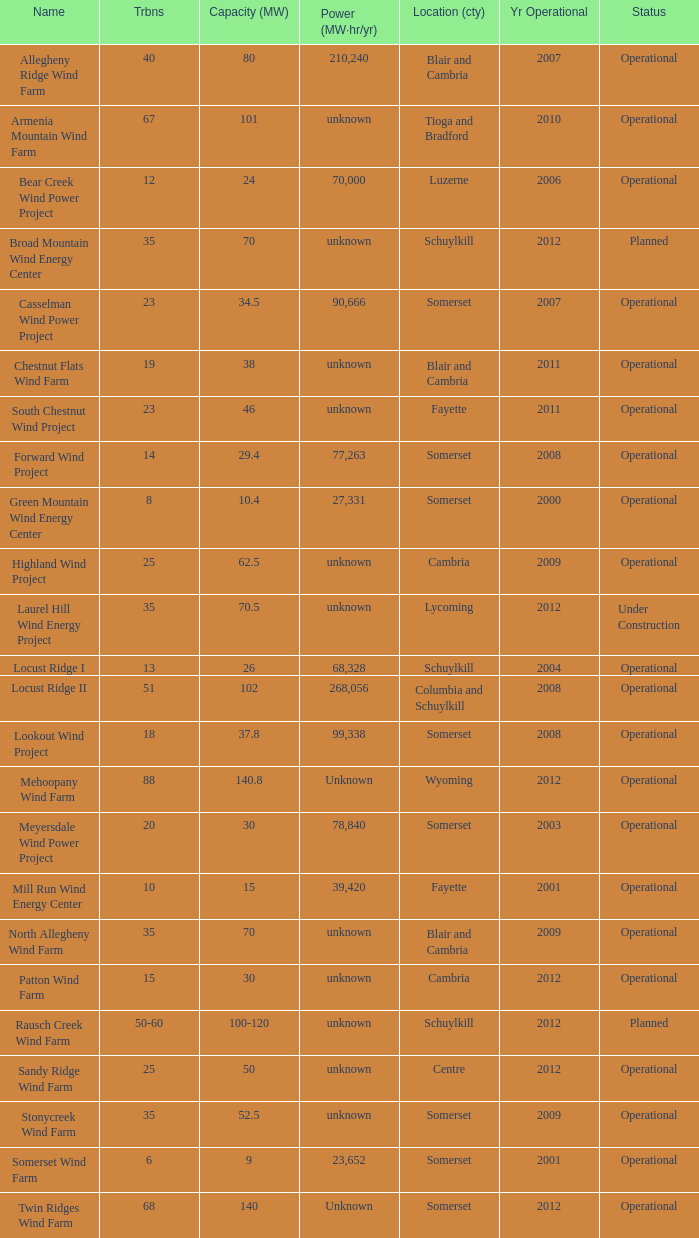What locations are considered centre? Unknown. 